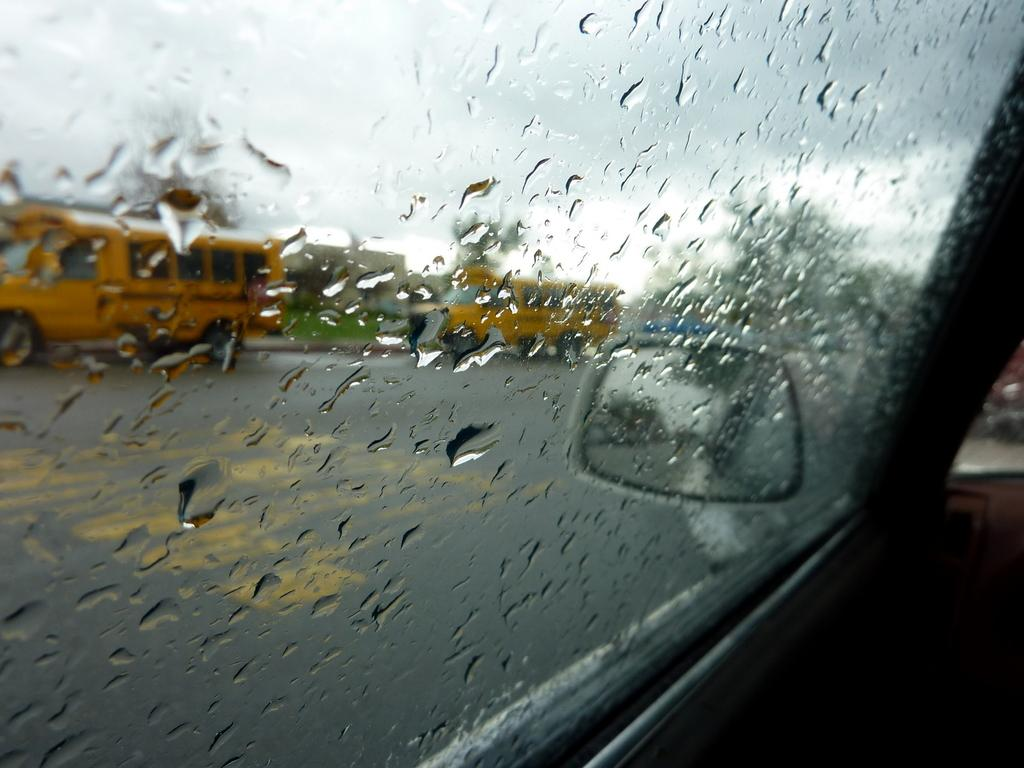What is the condition of the window in the image? There are water droplets on the window of a vehicle in the image. What type of vehicles can be seen in the image? There are buses standing on the ground in the image. How would you describe the background of the image? The background of the image is slightly blurry. What type of pancake is being served at the club in the image? There is no club, pancake, or any food mentioned in the image. The image only shows water droplets on a vehicle's window and buses standing on the ground. 